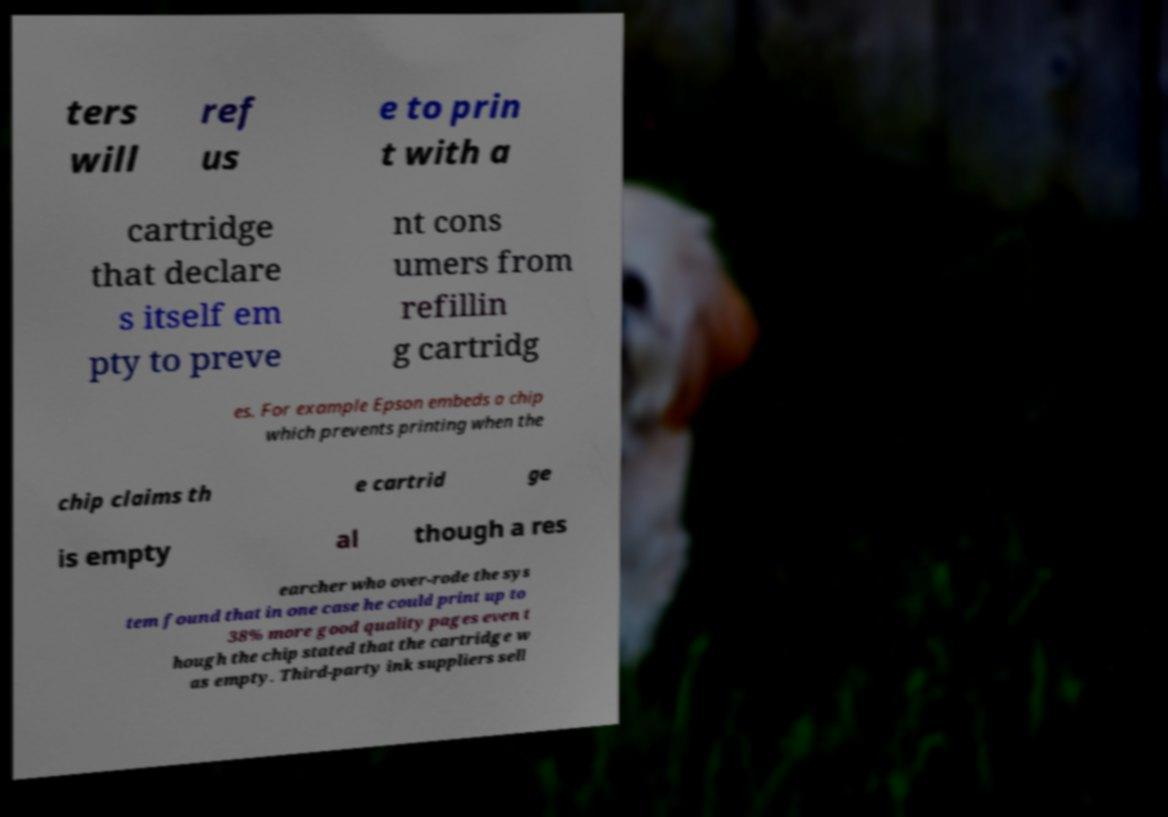There's text embedded in this image that I need extracted. Can you transcribe it verbatim? ters will ref us e to prin t with a cartridge that declare s itself em pty to preve nt cons umers from refillin g cartridg es. For example Epson embeds a chip which prevents printing when the chip claims th e cartrid ge is empty al though a res earcher who over-rode the sys tem found that in one case he could print up to 38% more good quality pages even t hough the chip stated that the cartridge w as empty. Third-party ink suppliers sell 